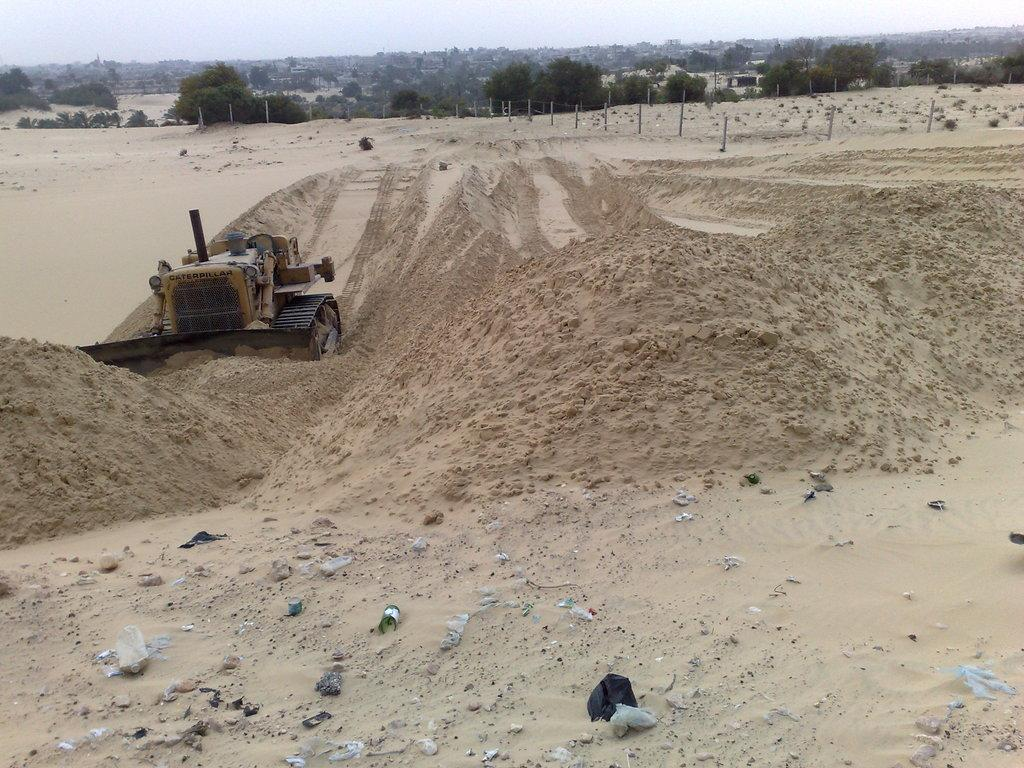What is the main subject of the image? There is a tractor in the image. Where is the tractor located? The tractor is on the sand. What can be seen in the background of the image? There are many trees in the background of the image. What type of barrier is visible in the image? A fence is visible in the image. What part of the natural environment is visible in the image? The sky is present in the image. Can you tell me how many yaks are grazing near the tractor in the image? There are no yaks present in the image; it features a tractor on the sand with trees, a fence, and the sky in the background. What is the tractor's brother doing in the image? There is no mention of a tractor's brother in the image or the provided facts. 